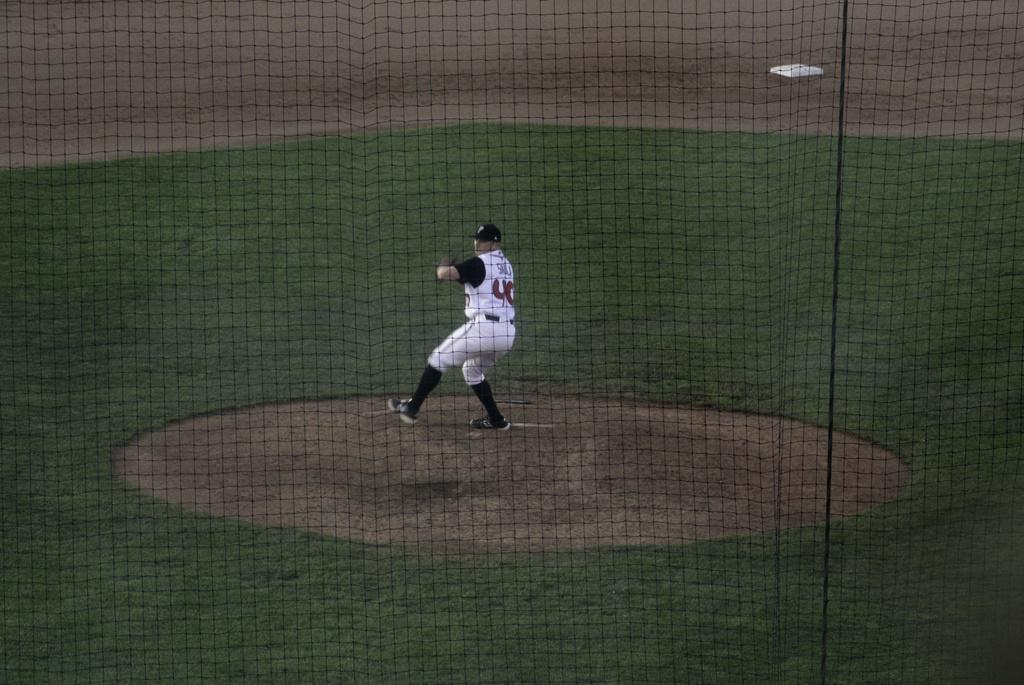What is present in the image that can be used for catching or holding objects? There is a net in the image. What type of surface is visible in the image? There is grass in the image. Who is present in the image? There is a man in the image. What is the man wearing? The man is wearing a white dress. What type of stone is being used to control the man's movements in the image? There is no stone present in the image, and the man's movements are not being controlled by any object. 